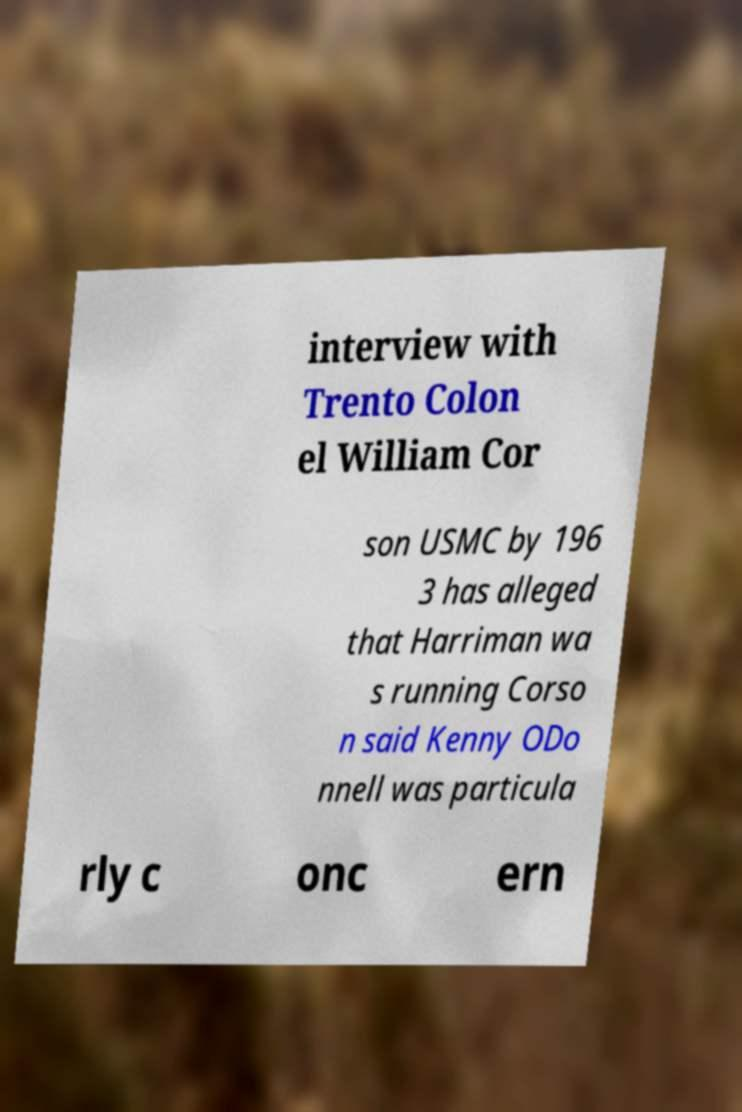I need the written content from this picture converted into text. Can you do that? interview with Trento Colon el William Cor son USMC by 196 3 has alleged that Harriman wa s running Corso n said Kenny ODo nnell was particula rly c onc ern 